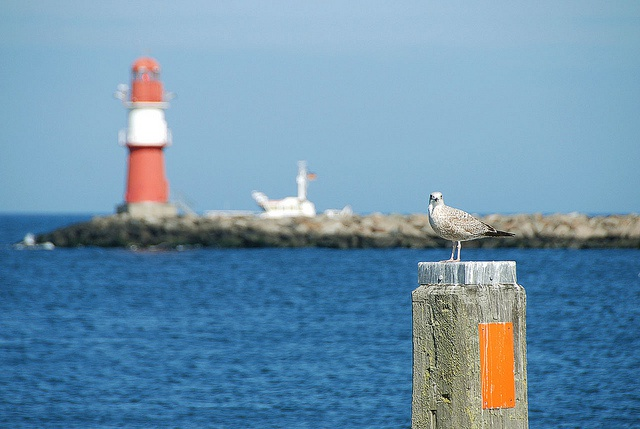Describe the objects in this image and their specific colors. I can see bird in lightblue, lightgray, darkgray, and gray tones and boat in lightblue, white, and darkgray tones in this image. 